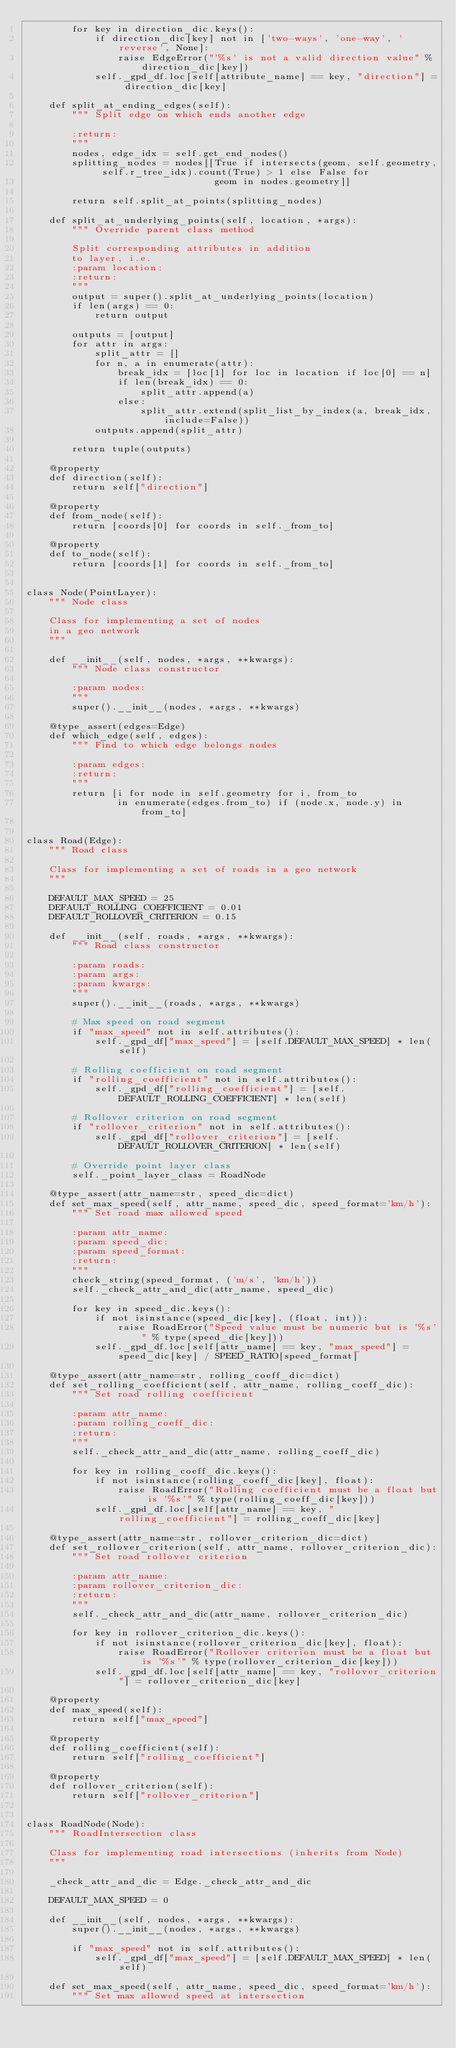<code> <loc_0><loc_0><loc_500><loc_500><_Python_>        for key in direction_dic.keys():
            if direction_dic[key] not in ['two-ways', 'one-way', 'reverse', None]:
                raise EdgeError("'%s' is not a valid direction value" % direction_dic[key])
            self._gpd_df.loc[self[attribute_name] == key, "direction"] = direction_dic[key]

    def split_at_ending_edges(self):
        """ Split edge on which ends another edge

        :return:
        """
        nodes, edge_idx = self.get_end_nodes()
        splitting_nodes = nodes[[True if intersects(geom, self.geometry, self.r_tree_idx).count(True) > 1 else False for
                                 geom in nodes.geometry]]

        return self.split_at_points(splitting_nodes)

    def split_at_underlying_points(self, location, *args):
        """ Override parent class method

        Split corresponding attributes in addition
        to layer, i.e.
        :param location:
        :return:
        """
        output = super().split_at_underlying_points(location)
        if len(args) == 0:
            return output

        outputs = [output]
        for attr in args:
            split_attr = []
            for n, a in enumerate(attr):
                break_idx = [loc[1] for loc in location if loc[0] == n]
                if len(break_idx) == 0:
                    split_attr.append(a)
                else:
                    split_attr.extend(split_list_by_index(a, break_idx, include=False))
            outputs.append(split_attr)

        return tuple(outputs)

    @property
    def direction(self):
        return self["direction"]

    @property
    def from_node(self):
        return [coords[0] for coords in self._from_to]

    @property
    def to_node(self):
        return [coords[1] for coords in self._from_to]


class Node(PointLayer):
    """ Node class

    Class for implementing a set of nodes
    in a geo network
    """

    def __init__(self, nodes, *args, **kwargs):
        """ Node class constructor

        :param nodes:
        """
        super().__init__(nodes, *args, **kwargs)

    @type_assert(edges=Edge)
    def which_edge(self, edges):
        """ Find to which edge belongs nodes

        :param edges:
        :return:
        """
        return [i for node in self.geometry for i, from_to
                in enumerate(edges.from_to) if (node.x, node.y) in from_to]


class Road(Edge):
    """ Road class

    Class for implementing a set of roads in a geo network
    """

    DEFAULT_MAX_SPEED = 25
    DEFAULT_ROLLING_COEFFICIENT = 0.01
    DEFAULT_ROLLOVER_CRITERION = 0.15

    def __init__(self, roads, *args, **kwargs):
        """ Road class constructor

        :param roads:
        :param args:
        :param kwargs:
        """
        super().__init__(roads, *args, **kwargs)

        # Max speed on road segment
        if "max_speed" not in self.attributes():
            self._gpd_df["max_speed"] = [self.DEFAULT_MAX_SPEED] * len(self)

        # Rolling coefficient on road segment
        if "rolling_coefficient" not in self.attributes():
            self._gpd_df["rolling_coefficient"] = [self.DEFAULT_ROLLING_COEFFICIENT] * len(self)

        # Rollover criterion on road segment
        if "rollover_criterion" not in self.attributes():
            self._gpd_df["rollover_criterion"] = [self.DEFAULT_ROLLOVER_CRITERION] * len(self)

        # Override point layer class
        self._point_layer_class = RoadNode

    @type_assert(attr_name=str, speed_dic=dict)
    def set_max_speed(self, attr_name, speed_dic, speed_format='km/h'):
        """ Set road max allowed speed

        :param attr_name:
        :param speed_dic:
        :param speed_format:
        :return:
        """
        check_string(speed_format, ('m/s', 'km/h'))
        self._check_attr_and_dic(attr_name, speed_dic)

        for key in speed_dic.keys():
            if not isinstance(speed_dic[key], (float, int)):
                raise RoadError("Speed value must be numeric but is '%s'" % type(speed_dic[key]))
            self._gpd_df.loc[self[attr_name] == key, "max_speed"] = speed_dic[key] / SPEED_RATIO[speed_format]

    @type_assert(attr_name=str, rolling_coeff_dic=dict)
    def set_rolling_coefficient(self, attr_name, rolling_coeff_dic):
        """ Set road rolling coefficient

        :param attr_name:
        :param rolling_coeff_dic:
        :return:
        """
        self._check_attr_and_dic(attr_name, rolling_coeff_dic)

        for key in rolling_coeff_dic.keys():
            if not isinstance(rolling_coeff_dic[key], float):
                raise RoadError("Rolling coefficient must be a float but is '%s'" % type(rolling_coeff_dic[key]))
            self._gpd_df.loc[self[attr_name] == key, "rolling_coefficient"] = rolling_coeff_dic[key]

    @type_assert(attr_name=str, rollover_criterion_dic=dict)
    def set_rollover_criterion(self, attr_name, rollover_criterion_dic):
        """ Set road rollover criterion

        :param attr_name:
        :param rollover_criterion_dic:
        :return:
        """
        self._check_attr_and_dic(attr_name, rollover_criterion_dic)

        for key in rollover_criterion_dic.keys():
            if not isinstance(rollover_criterion_dic[key], float):
                raise RoadError("Rollover criterion must be a float but is '%s'" % type(rollover_criterion_dic[key]))
            self._gpd_df.loc[self[attr_name] == key, "rollover_criterion"] = rollover_criterion_dic[key]

    @property
    def max_speed(self):
        return self["max_speed"]

    @property
    def rolling_coefficient(self):
        return self["rolling_coefficient"]

    @property
    def rollover_criterion(self):
        return self["rollover_criterion"]


class RoadNode(Node):
    """ RoadIntersection class

    Class for implementing road intersections (inherits from Node)
    """

    _check_attr_and_dic = Edge._check_attr_and_dic

    DEFAULT_MAX_SPEED = 0

    def __init__(self, nodes, *args, **kwargs):
        super().__init__(nodes, *args, **kwargs)

        if "max_speed" not in self.attributes():
            self._gpd_df["max_speed"] = [self.DEFAULT_MAX_SPEED] * len(self)

    def set_max_speed(self, attr_name, speed_dic, speed_format='km/h'):
        """ Set max allowed speed at intersection
</code> 